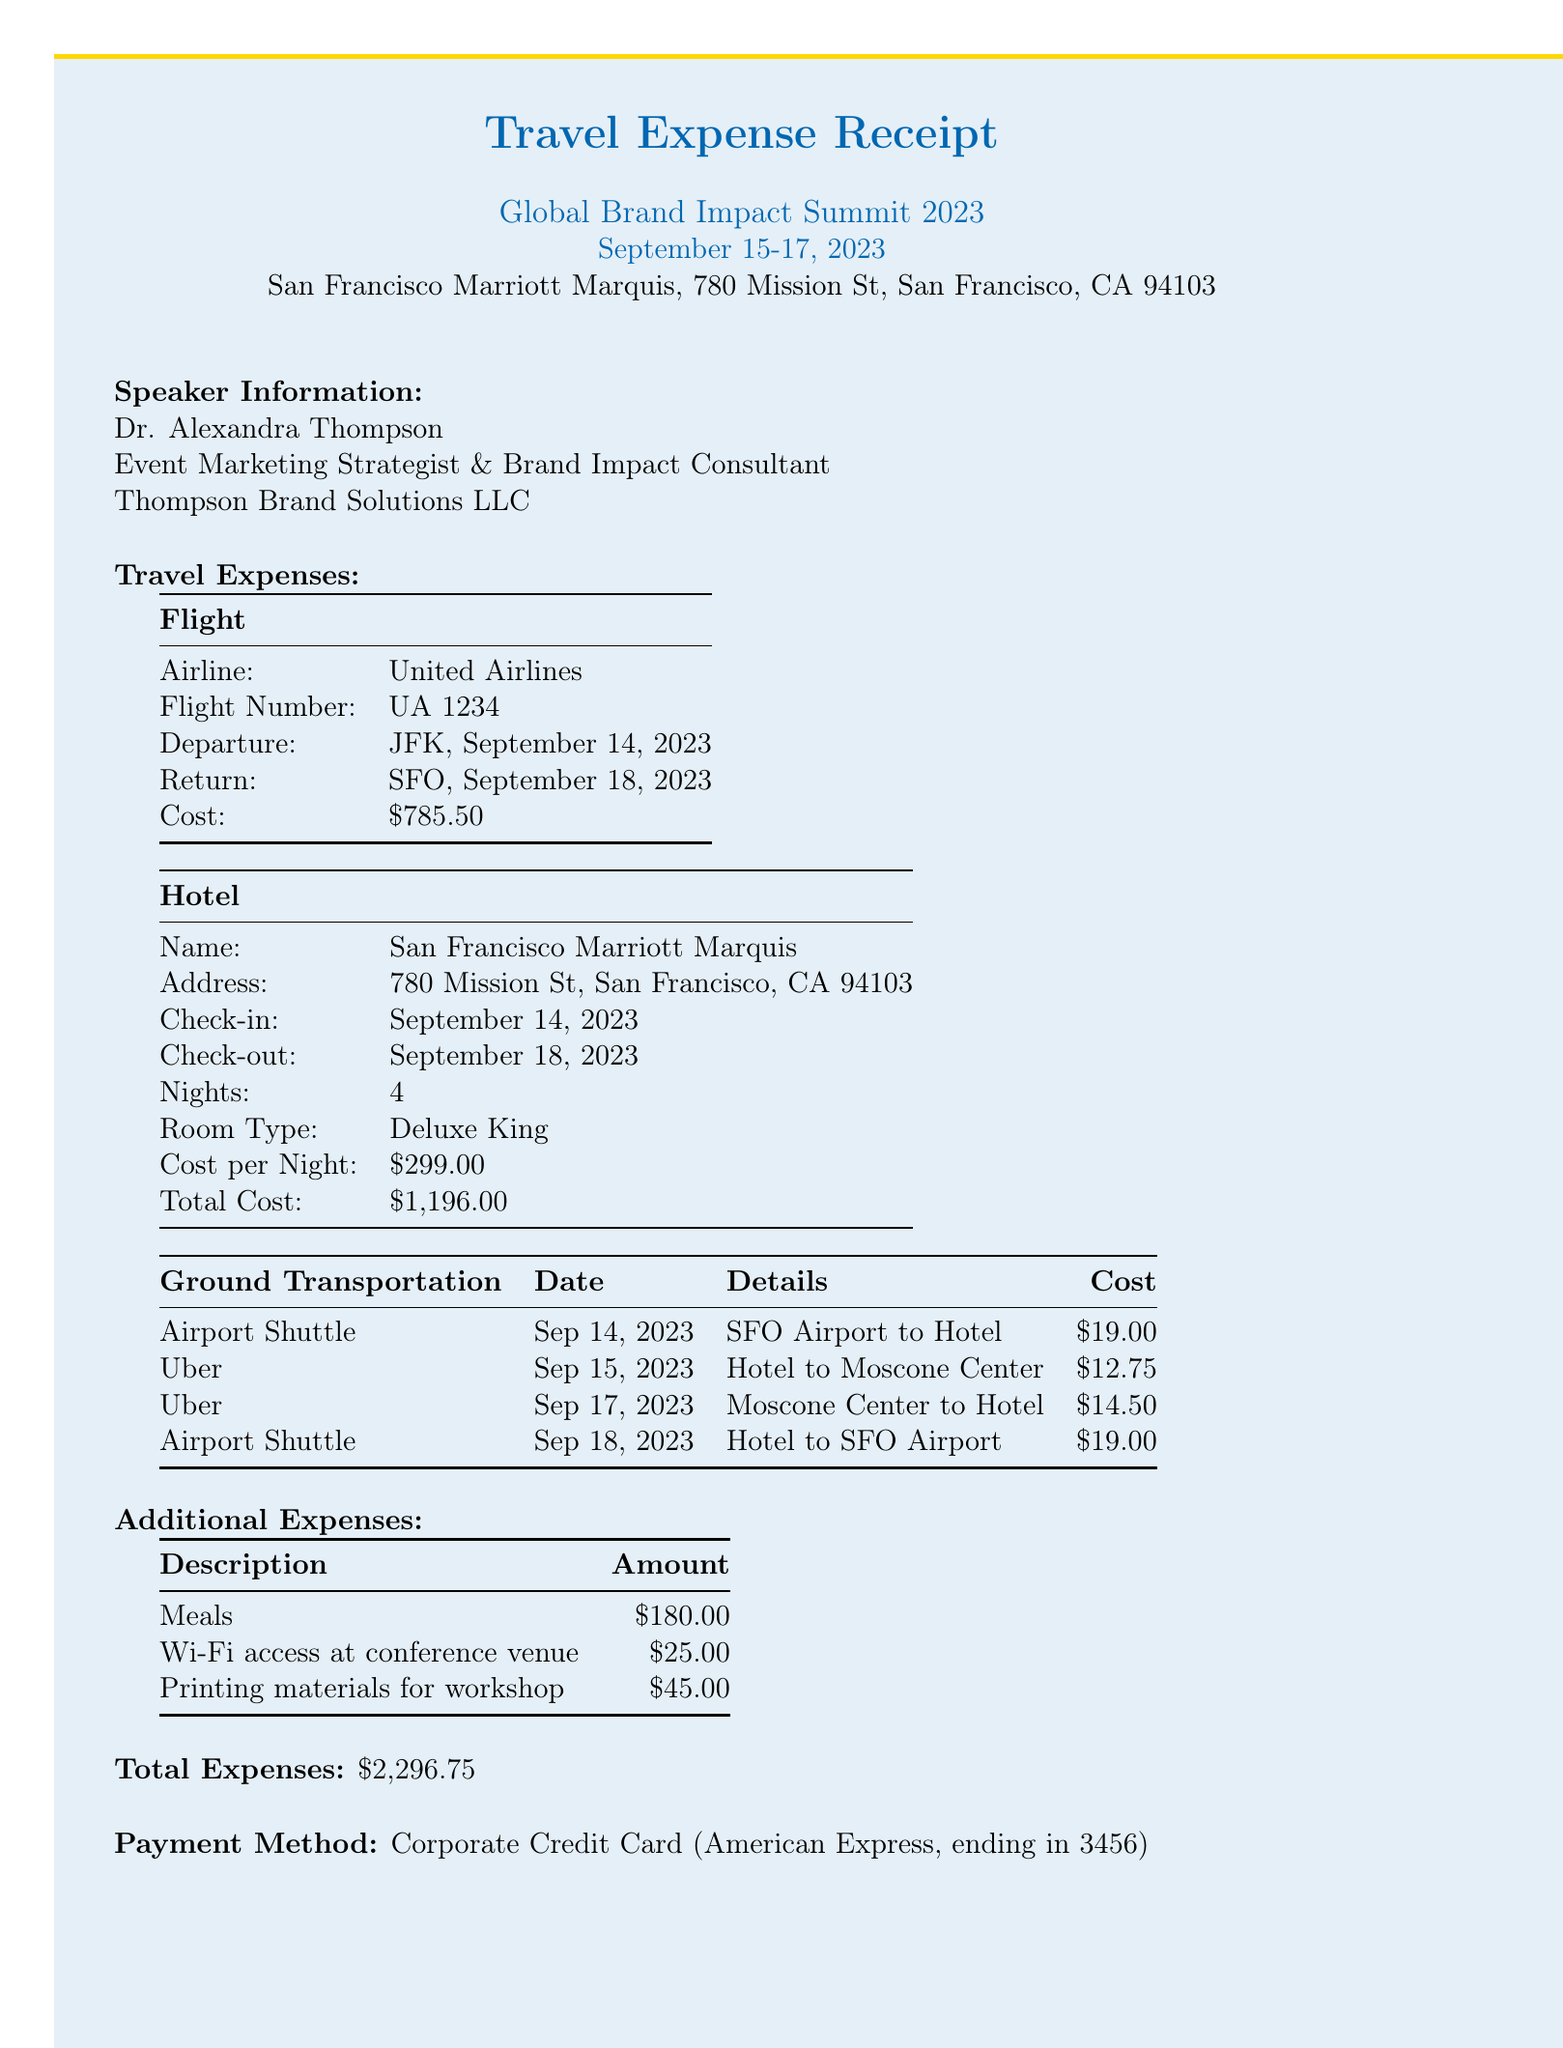What is the name of the event? The event name is specified in the document as the title of the event.
Answer: Global Brand Impact Summit 2023 What are the check-in and check-out dates for the hotel? The check-in and check-out dates for the hotel are found in the hotel section of the travel expenses.
Answer: September 14, 2023 & September 18, 2023 What was the total flight cost? The total flight cost is listed under travel expenses, specifically in the flight section.
Answer: $785.50 What type of room was booked at the hotel? The room type is specified in the hotel section of the document.
Answer: Deluxe King What is the total amount claimed for additional expenses? The total amount for additional expenses is found by summing the individual amounts listed under that section.
Answer: $250.00 How many nights did the speaker stay at the hotel? The number of nights is explicitly stated in the hotel information section of the document.
Answer: 4 What was the approval status of the expenses? The approval status is mentioned in the last section of the document.
Answer: Pending What is the payment method used for the expenses? The payment type is specified near the end of the document.
Answer: Corporate Credit Card What was the total cost of ground transportation? The total cost for ground transportation can be calculated from the individual transportation entries in the document.
Answer: $65.25 